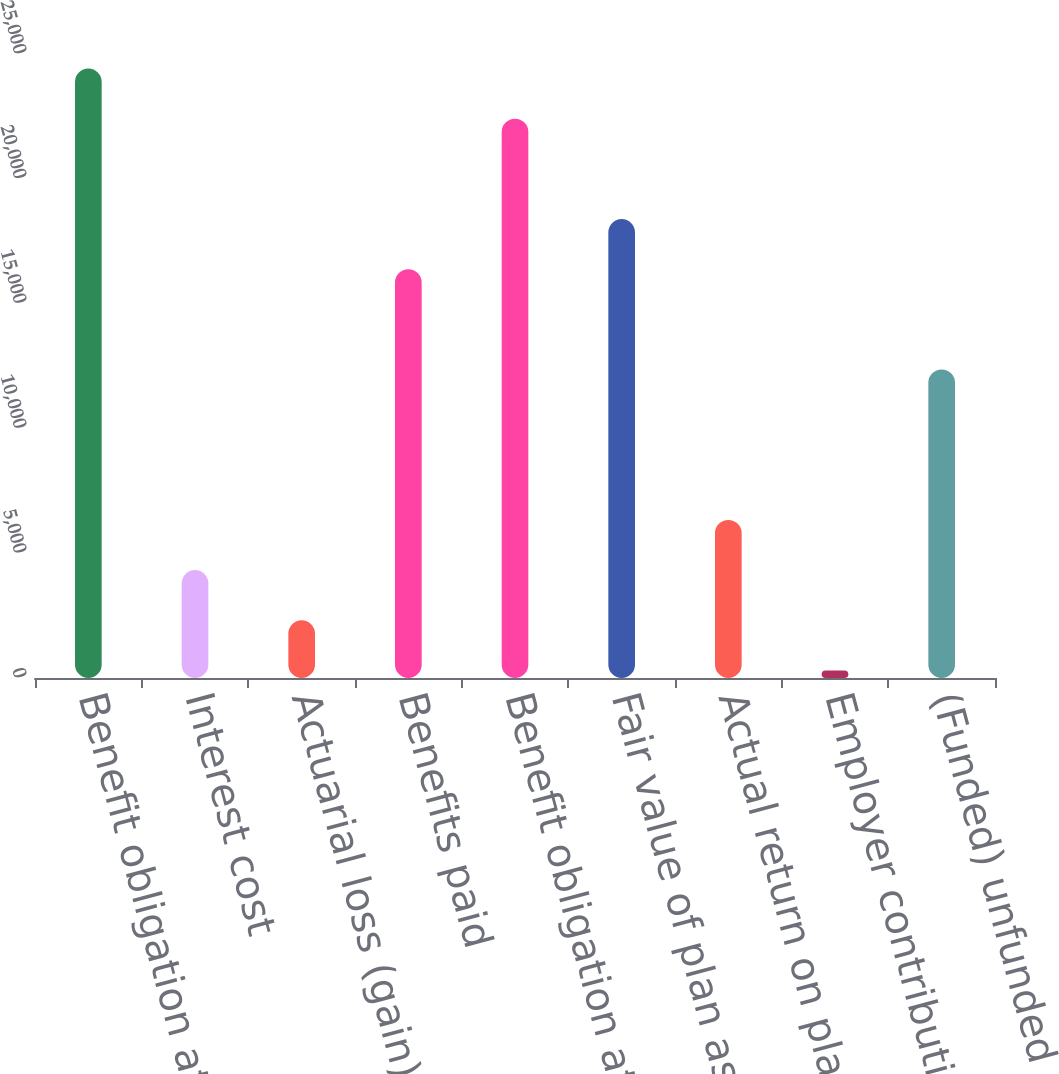<chart> <loc_0><loc_0><loc_500><loc_500><bar_chart><fcel>Benefit obligation at January<fcel>Interest cost<fcel>Actuarial loss (gain)<fcel>Benefits paid<fcel>Benefit obligation at December<fcel>Fair value of plan assets at<fcel>Actual return on plan assets<fcel>Employer contributions net<fcel>(Funded) unfunded status at<nl><fcel>24417.8<fcel>4323.8<fcel>2314.4<fcel>16380.2<fcel>22408.4<fcel>18389.6<fcel>6333.2<fcel>305<fcel>12361.4<nl></chart> 